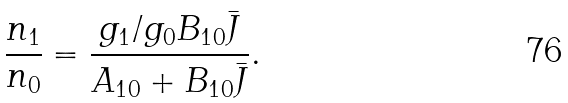<formula> <loc_0><loc_0><loc_500><loc_500>\frac { n _ { 1 } } { n _ { 0 } } = \frac { g _ { 1 } / g _ { 0 } B _ { 1 0 } \bar { J } } { A _ { 1 0 } + B _ { 1 0 } \bar { J } } .</formula> 